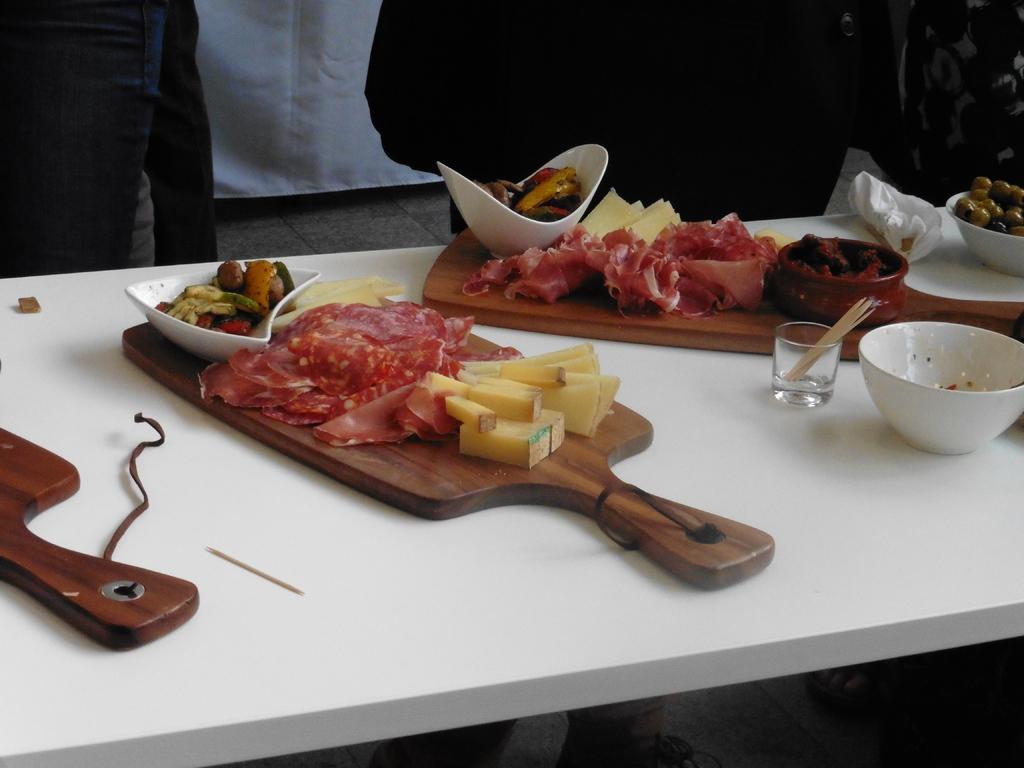Could you give a brief overview of what you see in this image? In this picture, there is a table on the table there are different types of food are presented. 